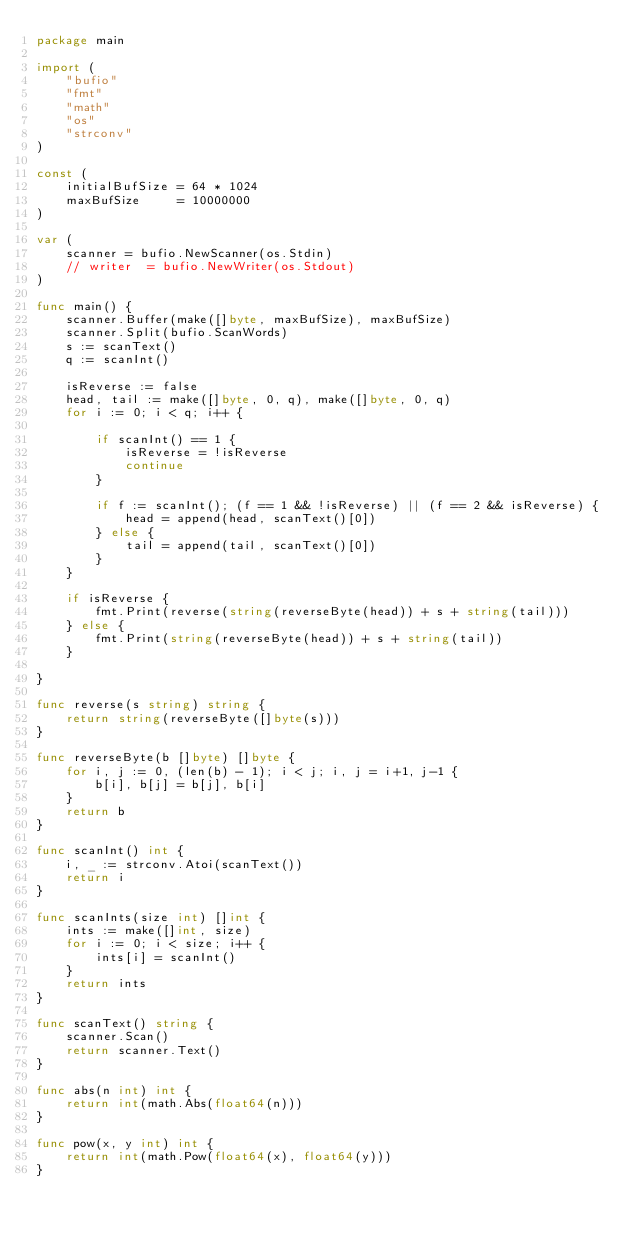<code> <loc_0><loc_0><loc_500><loc_500><_Go_>package main

import (
	"bufio"
	"fmt"
	"math"
	"os"
	"strconv"
)

const (
	initialBufSize = 64 * 1024
	maxBufSize     = 10000000
)

var (
	scanner = bufio.NewScanner(os.Stdin)
	// writer  = bufio.NewWriter(os.Stdout)
)

func main() {
	scanner.Buffer(make([]byte, maxBufSize), maxBufSize)
	scanner.Split(bufio.ScanWords)
	s := scanText()
	q := scanInt()

	isReverse := false
	head, tail := make([]byte, 0, q), make([]byte, 0, q)
	for i := 0; i < q; i++ {

		if scanInt() == 1 {
			isReverse = !isReverse
			continue
		}

		if f := scanInt(); (f == 1 && !isReverse) || (f == 2 && isReverse) {
			head = append(head, scanText()[0])
		} else {
			tail = append(tail, scanText()[0])
		}
	}

	if isReverse {
		fmt.Print(reverse(string(reverseByte(head)) + s + string(tail)))
	} else {
		fmt.Print(string(reverseByte(head)) + s + string(tail))
	}

}

func reverse(s string) string {
	return string(reverseByte([]byte(s)))
}

func reverseByte(b []byte) []byte {
	for i, j := 0, (len(b) - 1); i < j; i, j = i+1, j-1 {
		b[i], b[j] = b[j], b[i]
	}
	return b
}

func scanInt() int {
	i, _ := strconv.Atoi(scanText())
	return i
}

func scanInts(size int) []int {
	ints := make([]int, size)
	for i := 0; i < size; i++ {
		ints[i] = scanInt()
	}
	return ints
}

func scanText() string {
	scanner.Scan()
	return scanner.Text()
}

func abs(n int) int {
	return int(math.Abs(float64(n)))
}

func pow(x, y int) int {
	return int(math.Pow(float64(x), float64(y)))
}
</code> 